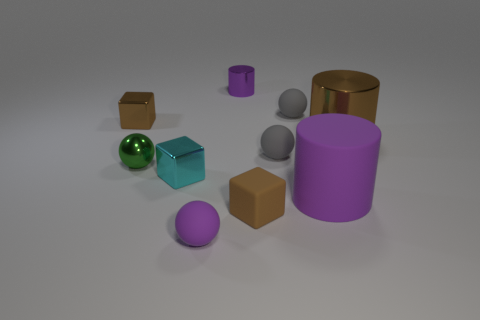What number of other things are the same shape as the big purple matte object?
Your response must be concise. 2. Does the rubber cylinder have the same size as the brown metal cylinder?
Give a very brief answer. Yes. Are there any tiny purple shiny cubes?
Ensure brevity in your answer.  No. Are there any other things that are made of the same material as the tiny purple sphere?
Keep it short and to the point. Yes. Is there a brown object made of the same material as the small cyan thing?
Ensure brevity in your answer.  Yes. There is a green ball that is the same size as the cyan metallic object; what is it made of?
Provide a succinct answer. Metal. What number of small purple shiny objects are the same shape as the cyan metal thing?
Offer a terse response. 0. There is a cylinder that is the same material as the tiny purple sphere; what is its size?
Provide a short and direct response. Large. What material is the thing that is in front of the big purple matte thing and on the left side of the purple metal cylinder?
Provide a short and direct response. Rubber. What number of brown metallic cylinders have the same size as the purple rubber cylinder?
Ensure brevity in your answer.  1. 